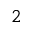<formula> <loc_0><loc_0><loc_500><loc_500>2</formula> 